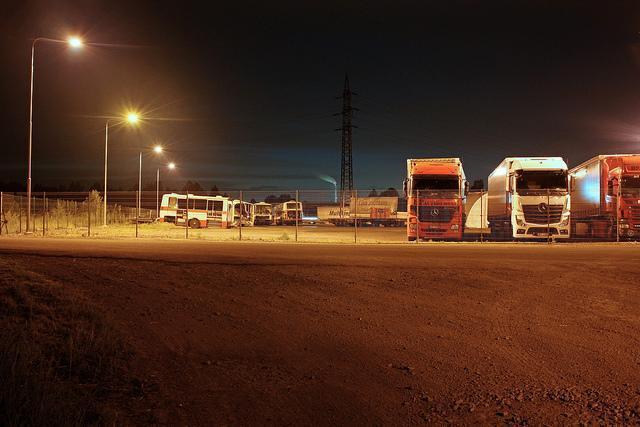How many street lamps are there?
Give a very brief answer. 4. How many buses are there?
Give a very brief answer. 2. How many trucks are there?
Give a very brief answer. 3. How many people walking on the beach?
Give a very brief answer. 0. 